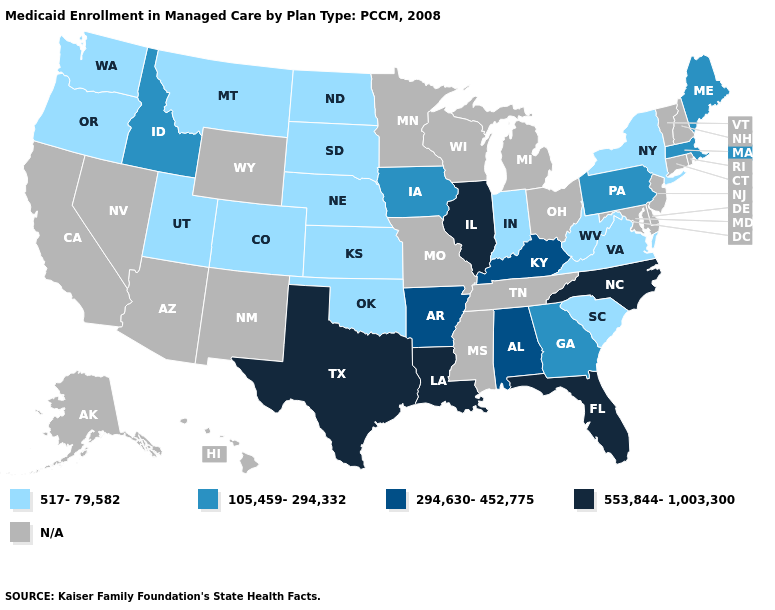What is the lowest value in the Northeast?
Short answer required. 517-79,582. Which states hav the highest value in the West?
Write a very short answer. Idaho. Does Nebraska have the lowest value in the MidWest?
Concise answer only. Yes. What is the lowest value in states that border South Carolina?
Answer briefly. 105,459-294,332. Which states have the lowest value in the USA?
Short answer required. Colorado, Indiana, Kansas, Montana, Nebraska, New York, North Dakota, Oklahoma, Oregon, South Carolina, South Dakota, Utah, Virginia, Washington, West Virginia. What is the highest value in the USA?
Quick response, please. 553,844-1,003,300. What is the value of Louisiana?
Quick response, please. 553,844-1,003,300. What is the value of Ohio?
Give a very brief answer. N/A. What is the lowest value in states that border New Mexico?
Concise answer only. 517-79,582. How many symbols are there in the legend?
Concise answer only. 5. What is the value of Connecticut?
Write a very short answer. N/A. Does Texas have the highest value in the South?
Concise answer only. Yes. 